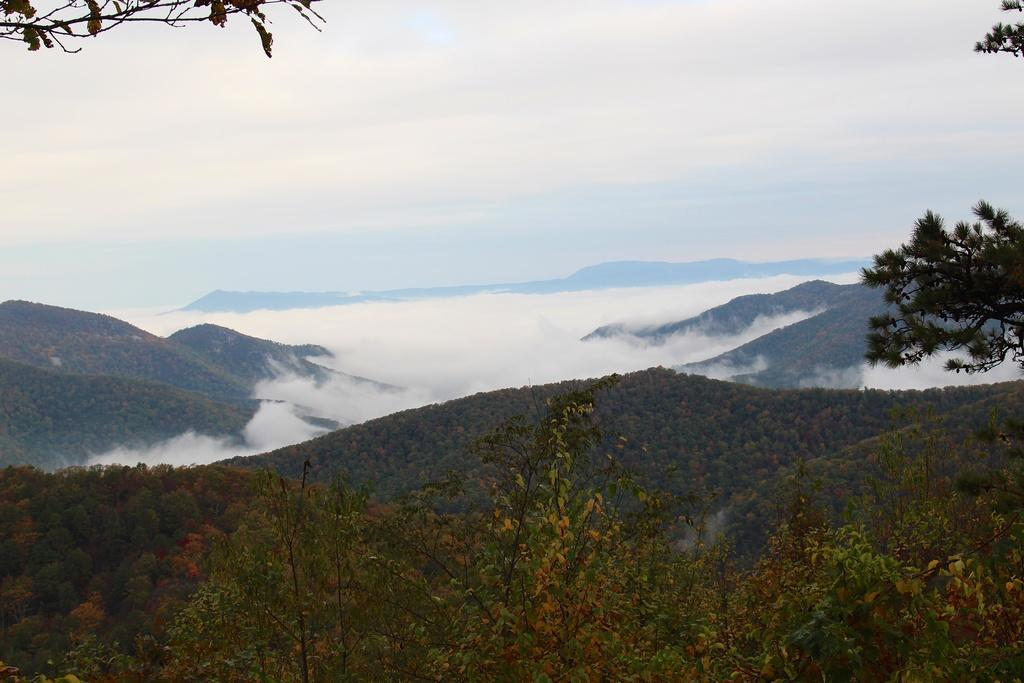What type of natural landform can be seen in the image? There are mountains in the image. What other natural elements are present in the image? There are trees in the image. What atmospheric condition is visible in the image? There is fog in the image. What is visible in the background of the image? The sky is visible in the image. What colors can be seen in the sky? The sky has a combination of white and blue colors. What type of metal is being advertised in the image? There is no metal or advertisement present in the image; it features mountains, trees, fog, and a sky with white and blue colors. 